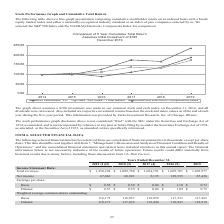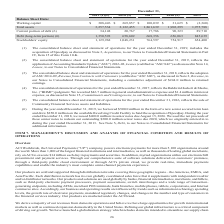According to Aci Worldwide's financial document, What was the working capital in 2018? According to the financial document, $269,857 (in thousands). The relevant text states: "Working capital $ 308,426 $ 269,857 $ 100,039 $ 31,625 $ (2,360 )..." Also, What was the working capital in 2019? According to the financial document, $308,426 (in thousands). The relevant text states: "Working capital $ 308,426 $ 269,857 $ 100,039 $ 31,625 $ (2,360 )..." Also, What was the total assets in 2015? According to the financial document, 1,975,788 (in thousands). The relevant text states: "al assets 3,257,534 2,122,455 1,861,639 1,902,295 1,975,788..." Also, can you calculate: What was the change in working capital between 2018 and 2019? Based on the calculation: $308,426-$269,857, the result is 38569 (in thousands). This is based on the information: "Working capital $ 308,426 $ 269,857 $ 100,039 $ 31,625 $ (2,360 ) Working capital $ 308,426 $ 269,857 $ 100,039 $ 31,625 $ (2,360 )..." The key data points involved are: 269,857, 308,426. Also, can you calculate: What was the change in current portion of debt between 2016 and 2017? Based on the calculation: 90,323-17,786, the result is 72537 (in thousands). This is based on the information: "Current portion of debt (6) 34,148 20,767 17,786 90,323 89,710 Current portion of debt (6) 34,148 20,767 17,786 90,323 89,710..." The key data points involved are: 17,786, 90,323. Also, can you calculate: What was the change in total assets between 2018 and 2019? To answer this question, I need to perform calculations using the financial data. The calculation is: (3,257,534-2,122,455)/2,122,455, which equals 53.48 (percentage). This is based on the information: "Total assets 3,257,534 2,122,455 1,861,639 1,902,295 1,975,788 Total assets 3,257,534 2,122,455 1,861,639 1,902,295 1,975,788..." The key data points involved are: 2,122,455, 3,257,534. 